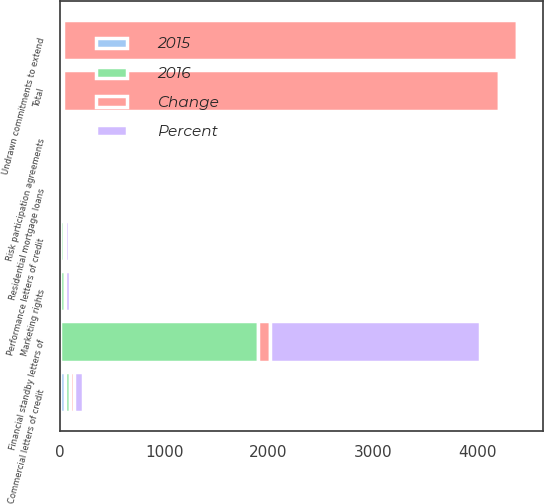Convert chart to OTSL. <chart><loc_0><loc_0><loc_500><loc_500><stacked_bar_chart><ecel><fcel>Undrawn commitments to extend<fcel>Financial standby letters of<fcel>Performance letters of credit<fcel>Commercial letters of credit<fcel>Marketing rights<fcel>Risk participation agreements<fcel>Residential mortgage loans<fcel>Total<nl><fcel>2016<fcel>26.5<fcel>1892<fcel>40<fcel>43<fcel>44<fcel>19<fcel>8<fcel>26.5<nl><fcel>Percent<fcel>26.5<fcel>2010<fcel>42<fcel>87<fcel>47<fcel>26<fcel>10<fcel>26.5<nl><fcel>Change<fcel>4348<fcel>118<fcel>2<fcel>44<fcel>3<fcel>7<fcel>2<fcel>4172<nl><fcel>2015<fcel>8<fcel>6<fcel>5<fcel>51<fcel>6<fcel>27<fcel>20<fcel>7<nl></chart> 